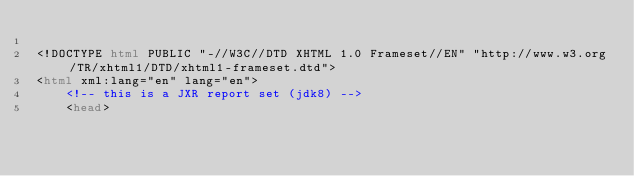<code> <loc_0><loc_0><loc_500><loc_500><_HTML_>
<!DOCTYPE html PUBLIC "-//W3C//DTD XHTML 1.0 Frameset//EN" "http://www.w3.org/TR/xhtml1/DTD/xhtml1-frameset.dtd">
<html xml:lang="en" lang="en">
    <!-- this is a JXR report set (jdk8) -->
    <head></code> 